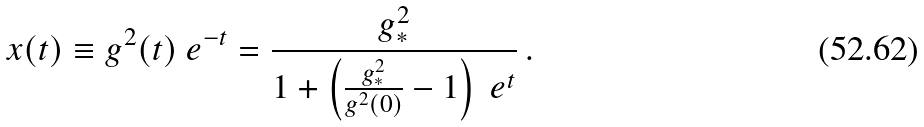Convert formula to latex. <formula><loc_0><loc_0><loc_500><loc_500>x ( t ) \equiv g ^ { 2 } ( t ) \ e ^ { - t } = \frac { g _ { * } ^ { 2 } } { 1 + \left ( \frac { g _ { * } ^ { 2 } } { g ^ { 2 } ( 0 ) } - 1 \right ) \ e ^ { t } } \, .</formula> 